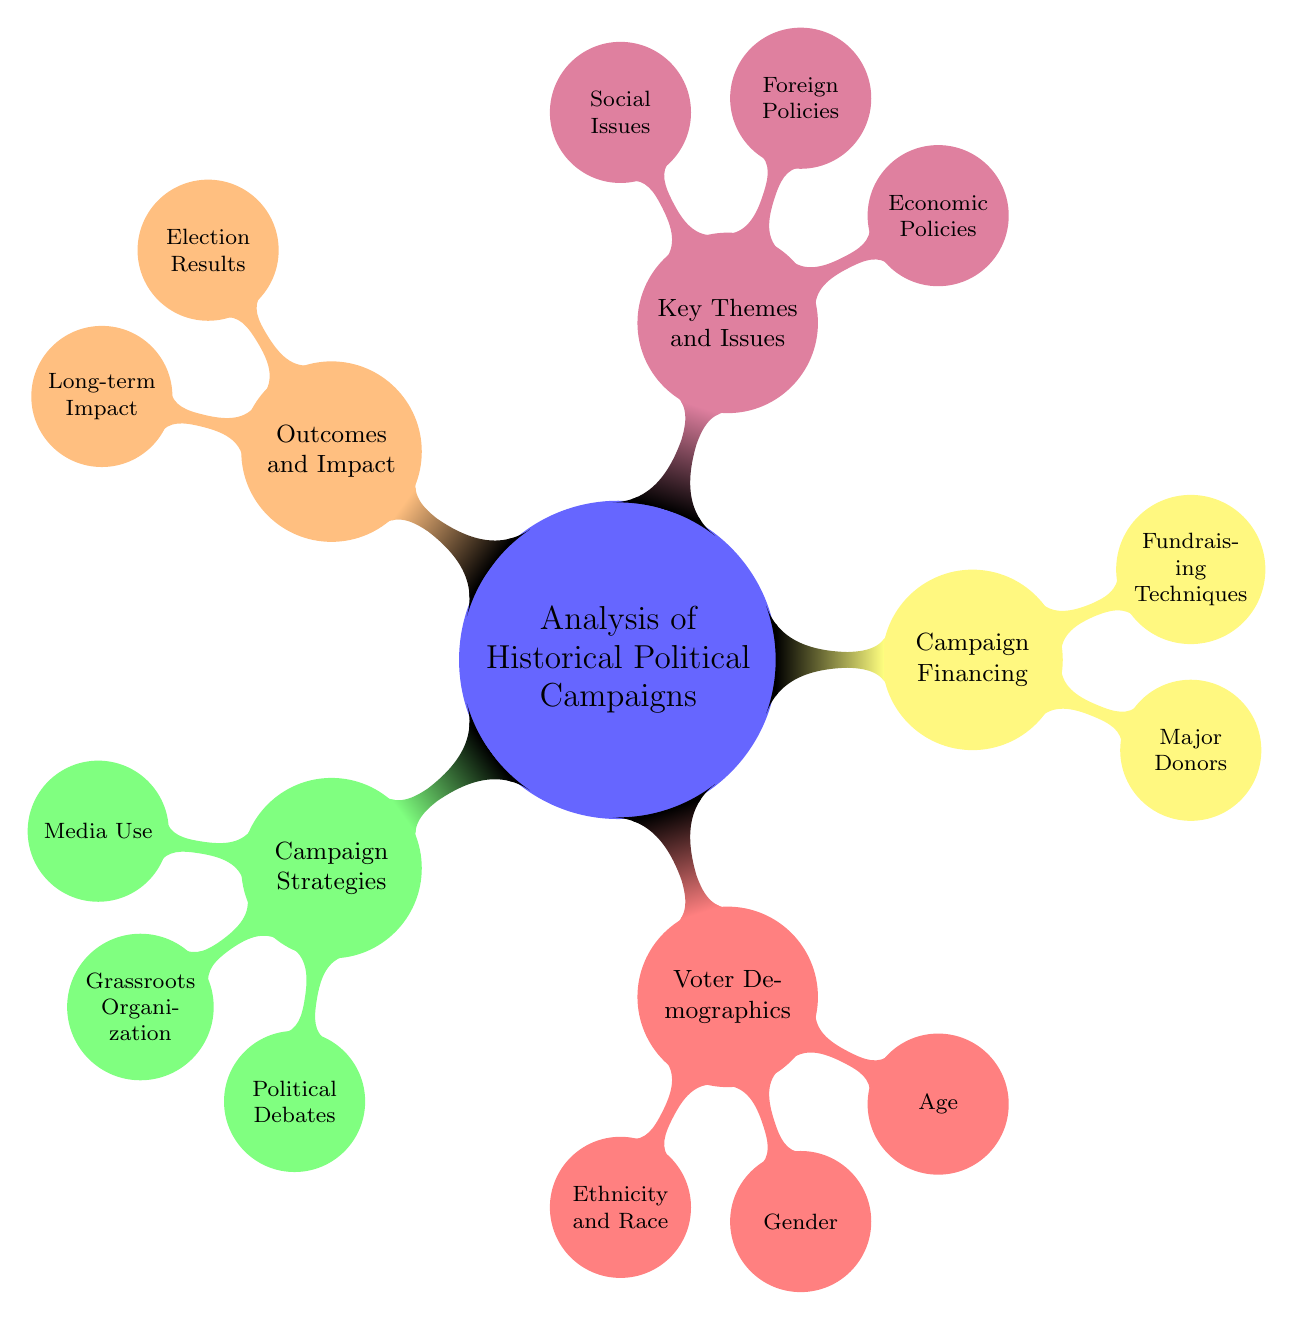What are the main categories in the mind map? The main categories are the top-level nodes originating from the central concept. They include Campaign Strategies, Voter Demographics, Campaign Financing, Key Themes and Issues, and Outcomes and Impact.
Answer: Campaign Strategies, Voter Demographics, Campaign Financing, Key Themes and Issues, Outcomes and Impact How many subcategories does Campaign Strategies have? To find this, we count the nodes connected to the Campaign Strategies node. There are three subcategories: Media Use, Grassroots Organization, and Political Debates.
Answer: Three Which campaign used social media as a strategy? By referencing the media use examples under Campaign Strategies, Obama’s 2008 Campaign is explicitly mentioned as utilizing social media effectively during the election.
Answer: Obama's 2008 Campaign Which voter demographic is highlighted under Gender? The Gender subcategory includes two highlighted voters: Women's Vote influenced by the 19th Amendment and Suburban Women in the 2020 election. Therefore, one must recognize "Women's Vote" as the primary reference point here.
Answer: Women's Vote What are two examples of Major Donors listed in Campaign Financing? This involves finding the details provided under the Major Donors node. The diagram lists the Koch Brothers and George Soros as notable major donors in political campaigns.
Answer: Koch Brothers, George Soros How does the outcome of Bush vs. Gore 2000 fit into the Outcomes and Impact category? This examines the specific outcome and its categorization within the mind-map. The controversial nature of the Bush vs. Gore 2000 election is classified as an example of Election Results under Outcomes and Impact.
Answer: Controversial Outcomes What is one economic policy highlighted in the Key Themes and Issues category? From the Key Themes and Issues node, economic policies such as the New Deal and Reaganomics are listed, with Reaganomics recognized for its impact on shaping the economic landscape.
Answer: Reaganomics What demographic factor influenced the Youth Vote during the Vietnam War Era? The specific demographic factor is connected through the Age subcategory, which includes the mention of the Youth Vote during the Vietnam War Era as a critical aspect of voter behavior at the time.
Answer: Vietnam War Era Which fundraising technique is associated with Bernie Sanders in Campaign Financing? To find this, we look under Fundraising Techniques; it states that crowdsourcing is a noted technique used by Bernie Sanders in his campaign efforts.
Answer: Crowdsourcing 